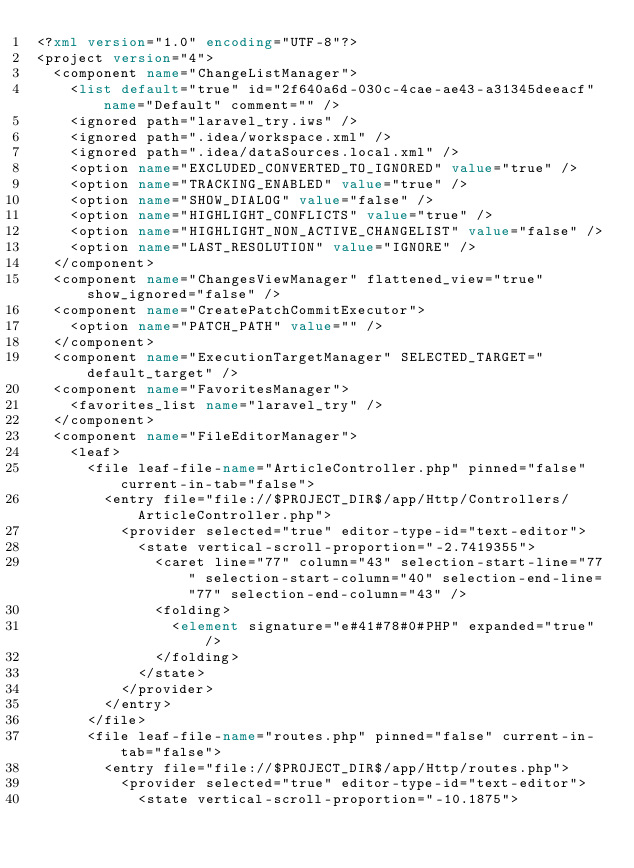Convert code to text. <code><loc_0><loc_0><loc_500><loc_500><_XML_><?xml version="1.0" encoding="UTF-8"?>
<project version="4">
  <component name="ChangeListManager">
    <list default="true" id="2f640a6d-030c-4cae-ae43-a31345deeacf" name="Default" comment="" />
    <ignored path="laravel_try.iws" />
    <ignored path=".idea/workspace.xml" />
    <ignored path=".idea/dataSources.local.xml" />
    <option name="EXCLUDED_CONVERTED_TO_IGNORED" value="true" />
    <option name="TRACKING_ENABLED" value="true" />
    <option name="SHOW_DIALOG" value="false" />
    <option name="HIGHLIGHT_CONFLICTS" value="true" />
    <option name="HIGHLIGHT_NON_ACTIVE_CHANGELIST" value="false" />
    <option name="LAST_RESOLUTION" value="IGNORE" />
  </component>
  <component name="ChangesViewManager" flattened_view="true" show_ignored="false" />
  <component name="CreatePatchCommitExecutor">
    <option name="PATCH_PATH" value="" />
  </component>
  <component name="ExecutionTargetManager" SELECTED_TARGET="default_target" />
  <component name="FavoritesManager">
    <favorites_list name="laravel_try" />
  </component>
  <component name="FileEditorManager">
    <leaf>
      <file leaf-file-name="ArticleController.php" pinned="false" current-in-tab="false">
        <entry file="file://$PROJECT_DIR$/app/Http/Controllers/ArticleController.php">
          <provider selected="true" editor-type-id="text-editor">
            <state vertical-scroll-proportion="-2.7419355">
              <caret line="77" column="43" selection-start-line="77" selection-start-column="40" selection-end-line="77" selection-end-column="43" />
              <folding>
                <element signature="e#41#78#0#PHP" expanded="true" />
              </folding>
            </state>
          </provider>
        </entry>
      </file>
      <file leaf-file-name="routes.php" pinned="false" current-in-tab="false">
        <entry file="file://$PROJECT_DIR$/app/Http/routes.php">
          <provider selected="true" editor-type-id="text-editor">
            <state vertical-scroll-proportion="-10.1875"></code> 